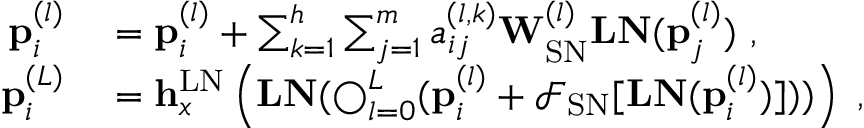<formula> <loc_0><loc_0><loc_500><loc_500>\begin{array} { r l } { p _ { i } ^ { ( l ) } } & = p _ { i } ^ { ( l ) } + \sum _ { k = 1 } ^ { h } \sum _ { j = 1 } ^ { m } a _ { i j } ^ { ( l , k ) } W _ { S N } ^ { ( l ) } L N ( p _ { j } ^ { ( l ) } ) , } \\ { p _ { i } ^ { ( L ) } } & = h _ { x } ^ { L N } \left ( L N ( \bigcirc _ { l = 0 } ^ { L } ( p _ { i } ^ { ( l ) } + \mathcal { F } _ { S N } [ L N ( p _ { i } ^ { ( l ) } ) ] ) ) \right ) , } \end{array}</formula> 